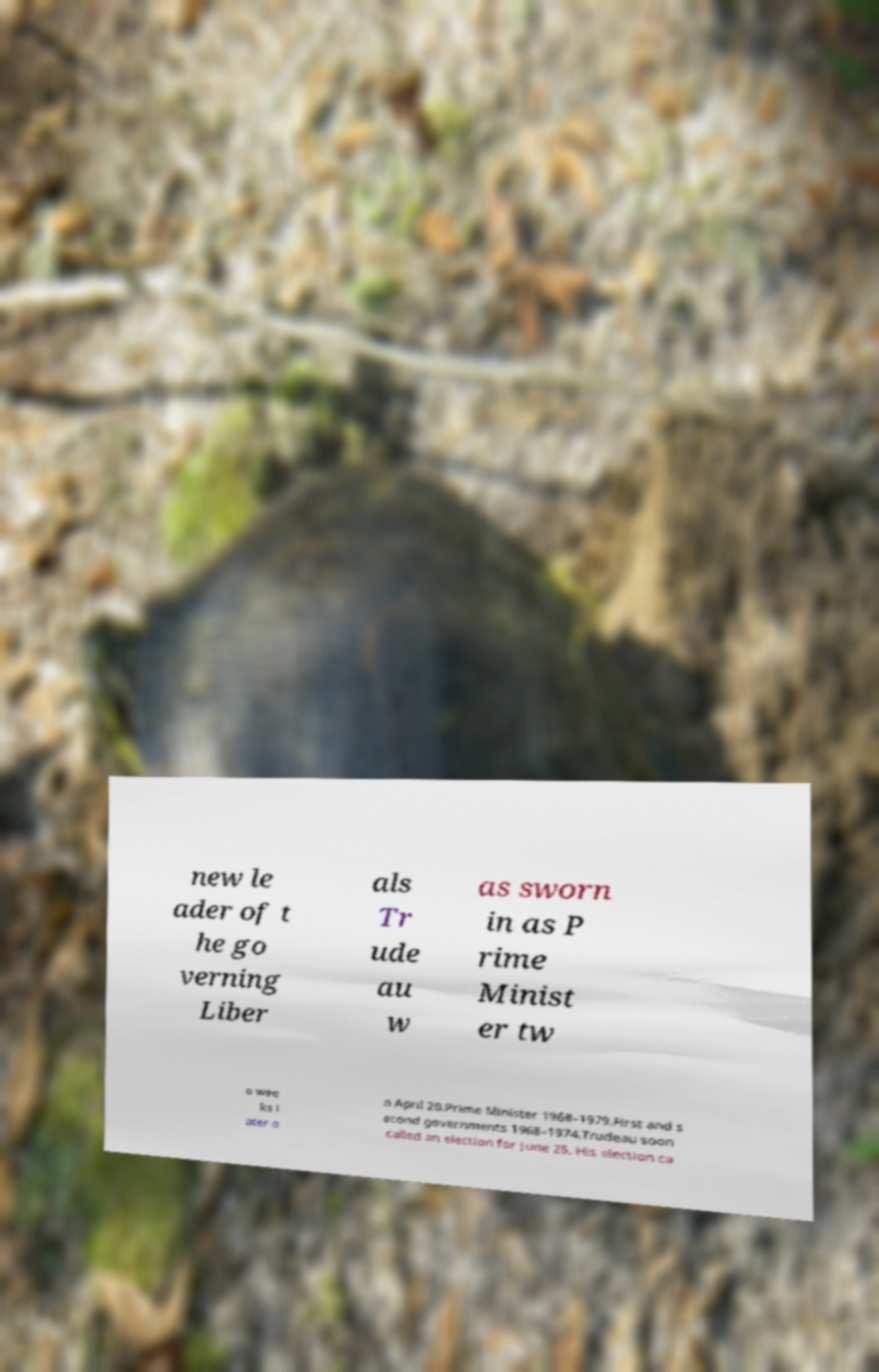Please identify and transcribe the text found in this image. new le ader of t he go verning Liber als Tr ude au w as sworn in as P rime Minist er tw o wee ks l ater o n April 20.Prime Minister 1968–1979.First and s econd governments 1968–1974.Trudeau soon called an election for June 25. His election ca 